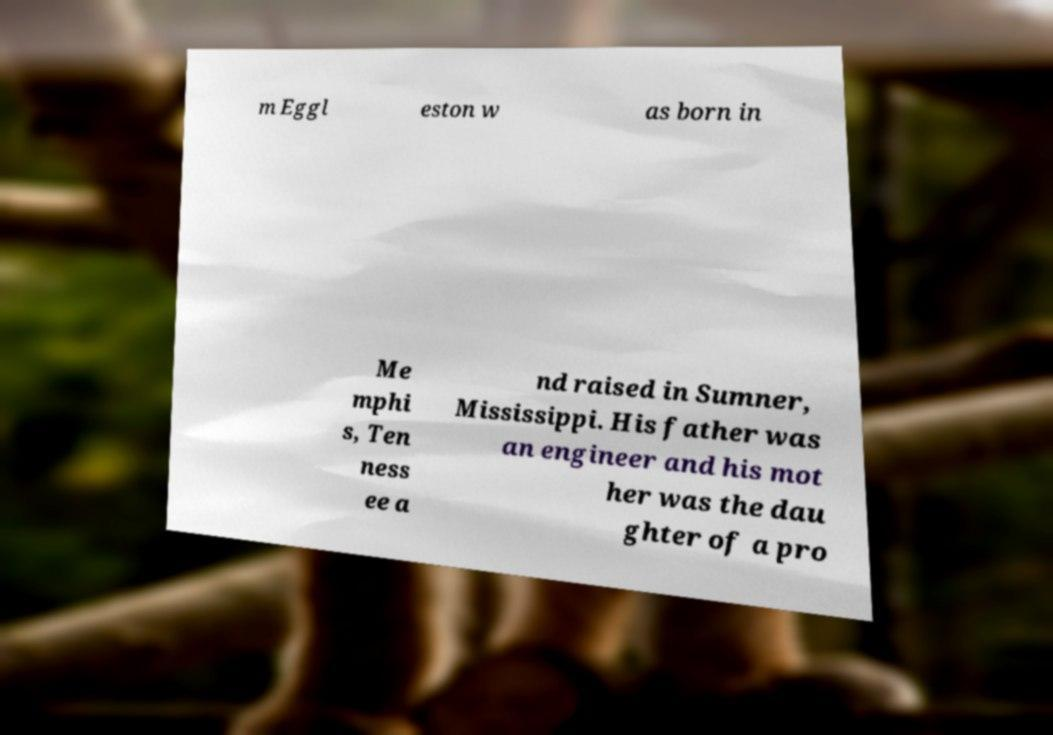Can you read and provide the text displayed in the image?This photo seems to have some interesting text. Can you extract and type it out for me? m Eggl eston w as born in Me mphi s, Ten ness ee a nd raised in Sumner, Mississippi. His father was an engineer and his mot her was the dau ghter of a pro 